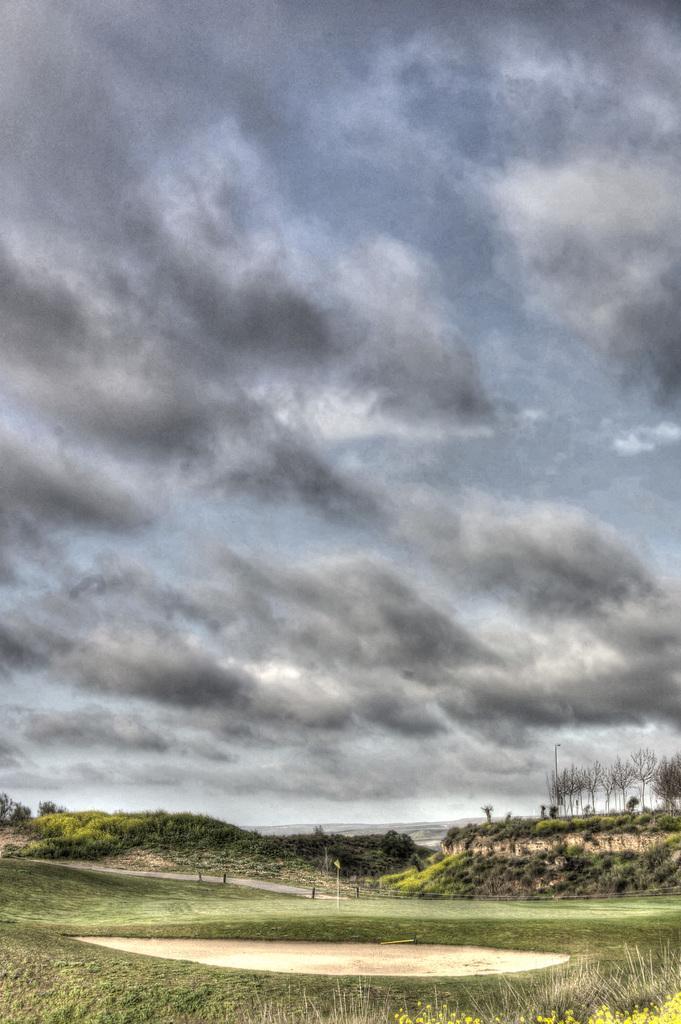In one or two sentences, can you explain what this image depicts? In this image we can see land with grass and dry tree. The sky is full of clouds. 